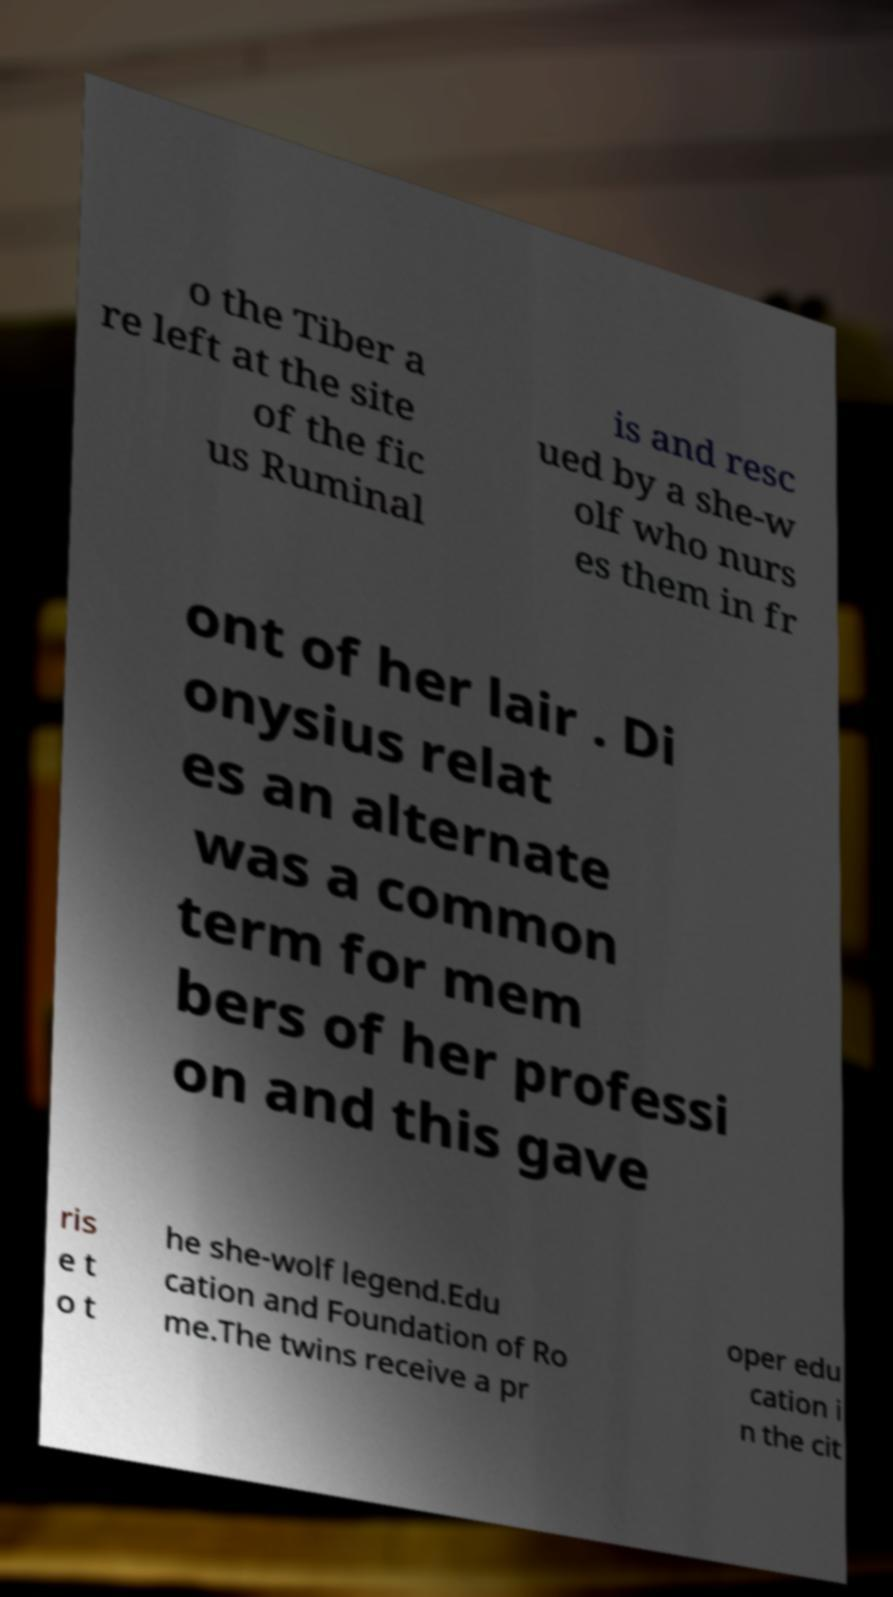For documentation purposes, I need the text within this image transcribed. Could you provide that? o the Tiber a re left at the site of the fic us Ruminal is and resc ued by a she-w olf who nurs es them in fr ont of her lair . Di onysius relat es an alternate was a common term for mem bers of her professi on and this gave ris e t o t he she-wolf legend.Edu cation and Foundation of Ro me.The twins receive a pr oper edu cation i n the cit 